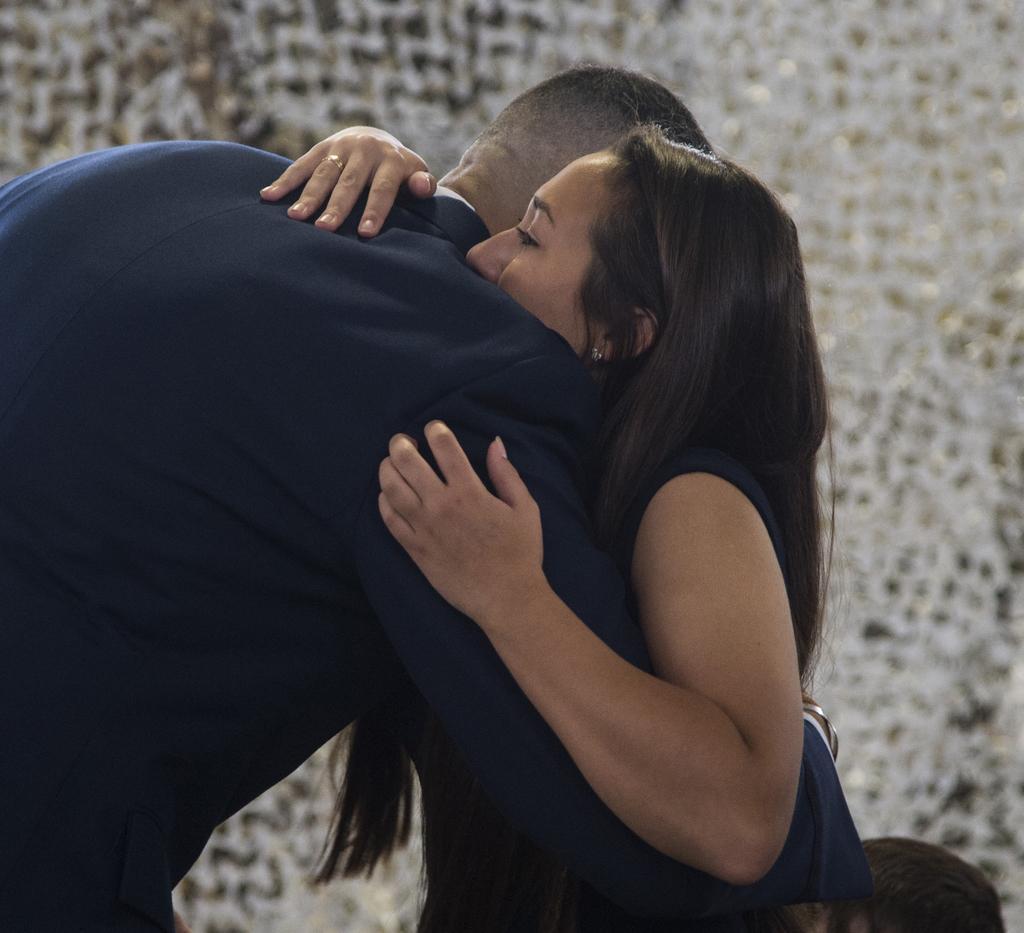How many people are in the image? There are two people in the image, a man and a woman. What are the man and woman doing in the image? The man and woman are hugging each other. What is the woman wearing in the image? The woman is wearing a blue dress. What can be seen in the background of the image? There is a wall in the background of the image. Can you describe the appearance of the wall? The wall is white in color with black dots. What type of crayon is the woman using to draw on the wall in the image? There is no crayon or drawing on the wall in the image; the woman is wearing a blue dress and hugging the man. How many clocks are visible on the wall in the image? There are no clocks visible on the wall in the image; the wall is white with black dots. 